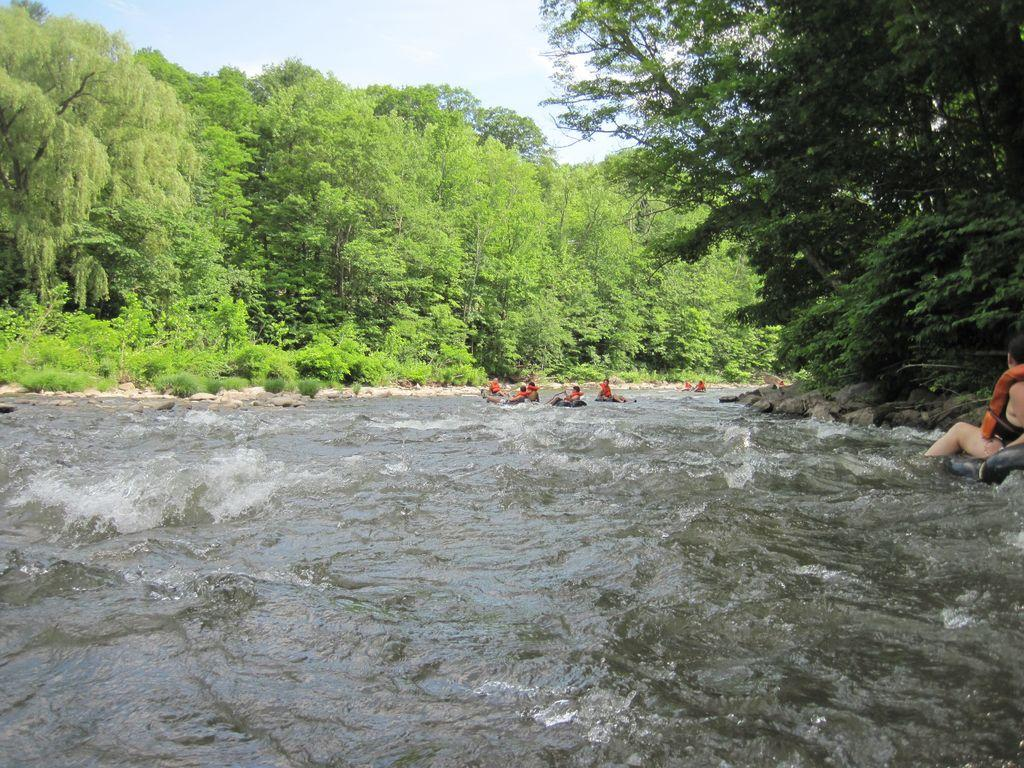What is the main feature in the middle of the image? There is a canal in the middle of the image. What can be seen on either side of the canal? Trees are present on either side of the canal. What are the people in the image doing? There are people sitting on boats in the canal. What is visible above the canal? The sky is visible above the canal. How many ducks are swimming in the street in the image? There are no ducks or streets present in the image; it features a canal with trees and people on boats. What emotion do the people in the image feel about their decision to sit on the boats? The image does not provide information about the emotions or decisions of the people in the image. 